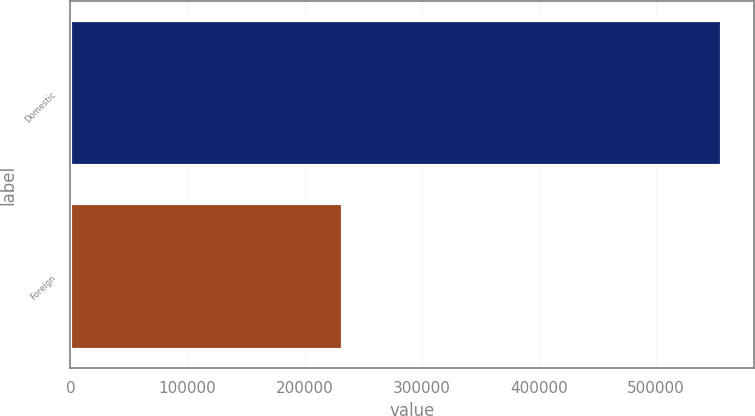Convert chart to OTSL. <chart><loc_0><loc_0><loc_500><loc_500><bar_chart><fcel>Domestic<fcel>Foreign<nl><fcel>556328<fcel>232450<nl></chart> 